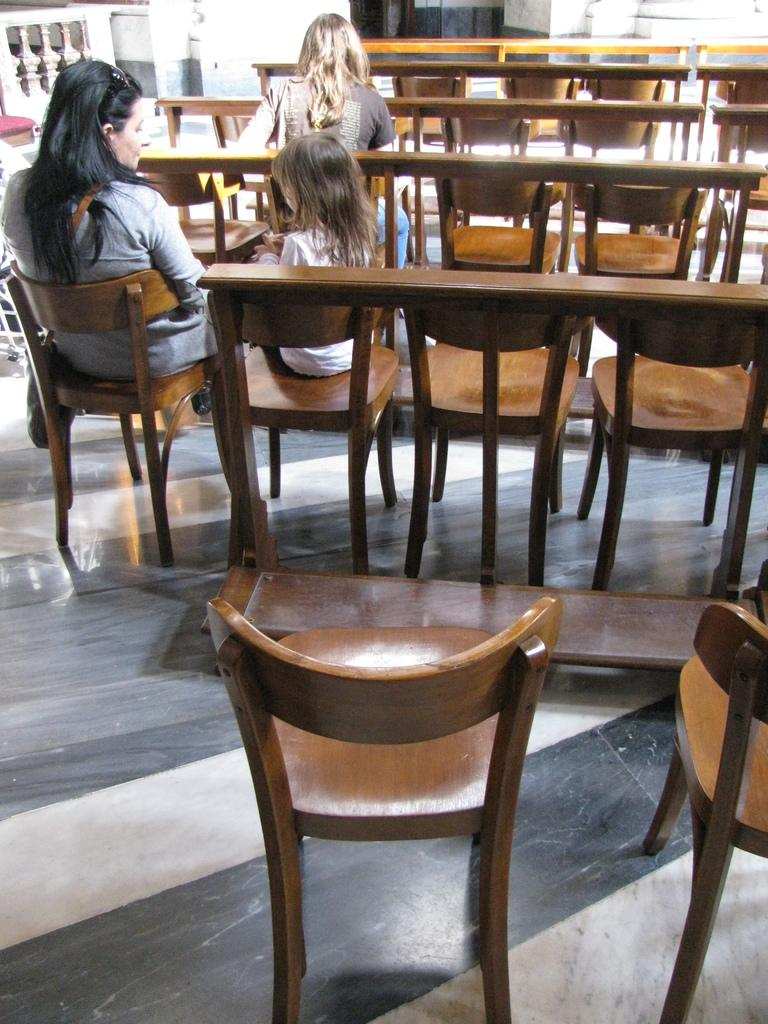How many people are in the image? There are two women and a girl in the image, making a total of three people. What are the people in the image doing? They are sitting in chairs. Are there any empty chairs in the image? Yes, there are empty chairs in the image. What can be seen in the background of the image? There is a cement railing in the background of the image. How many bricks are visible in the image? There are no bricks visible in the image. Can you see any kittens playing with a pie in the image? There are no kittens or pie present in the image. 